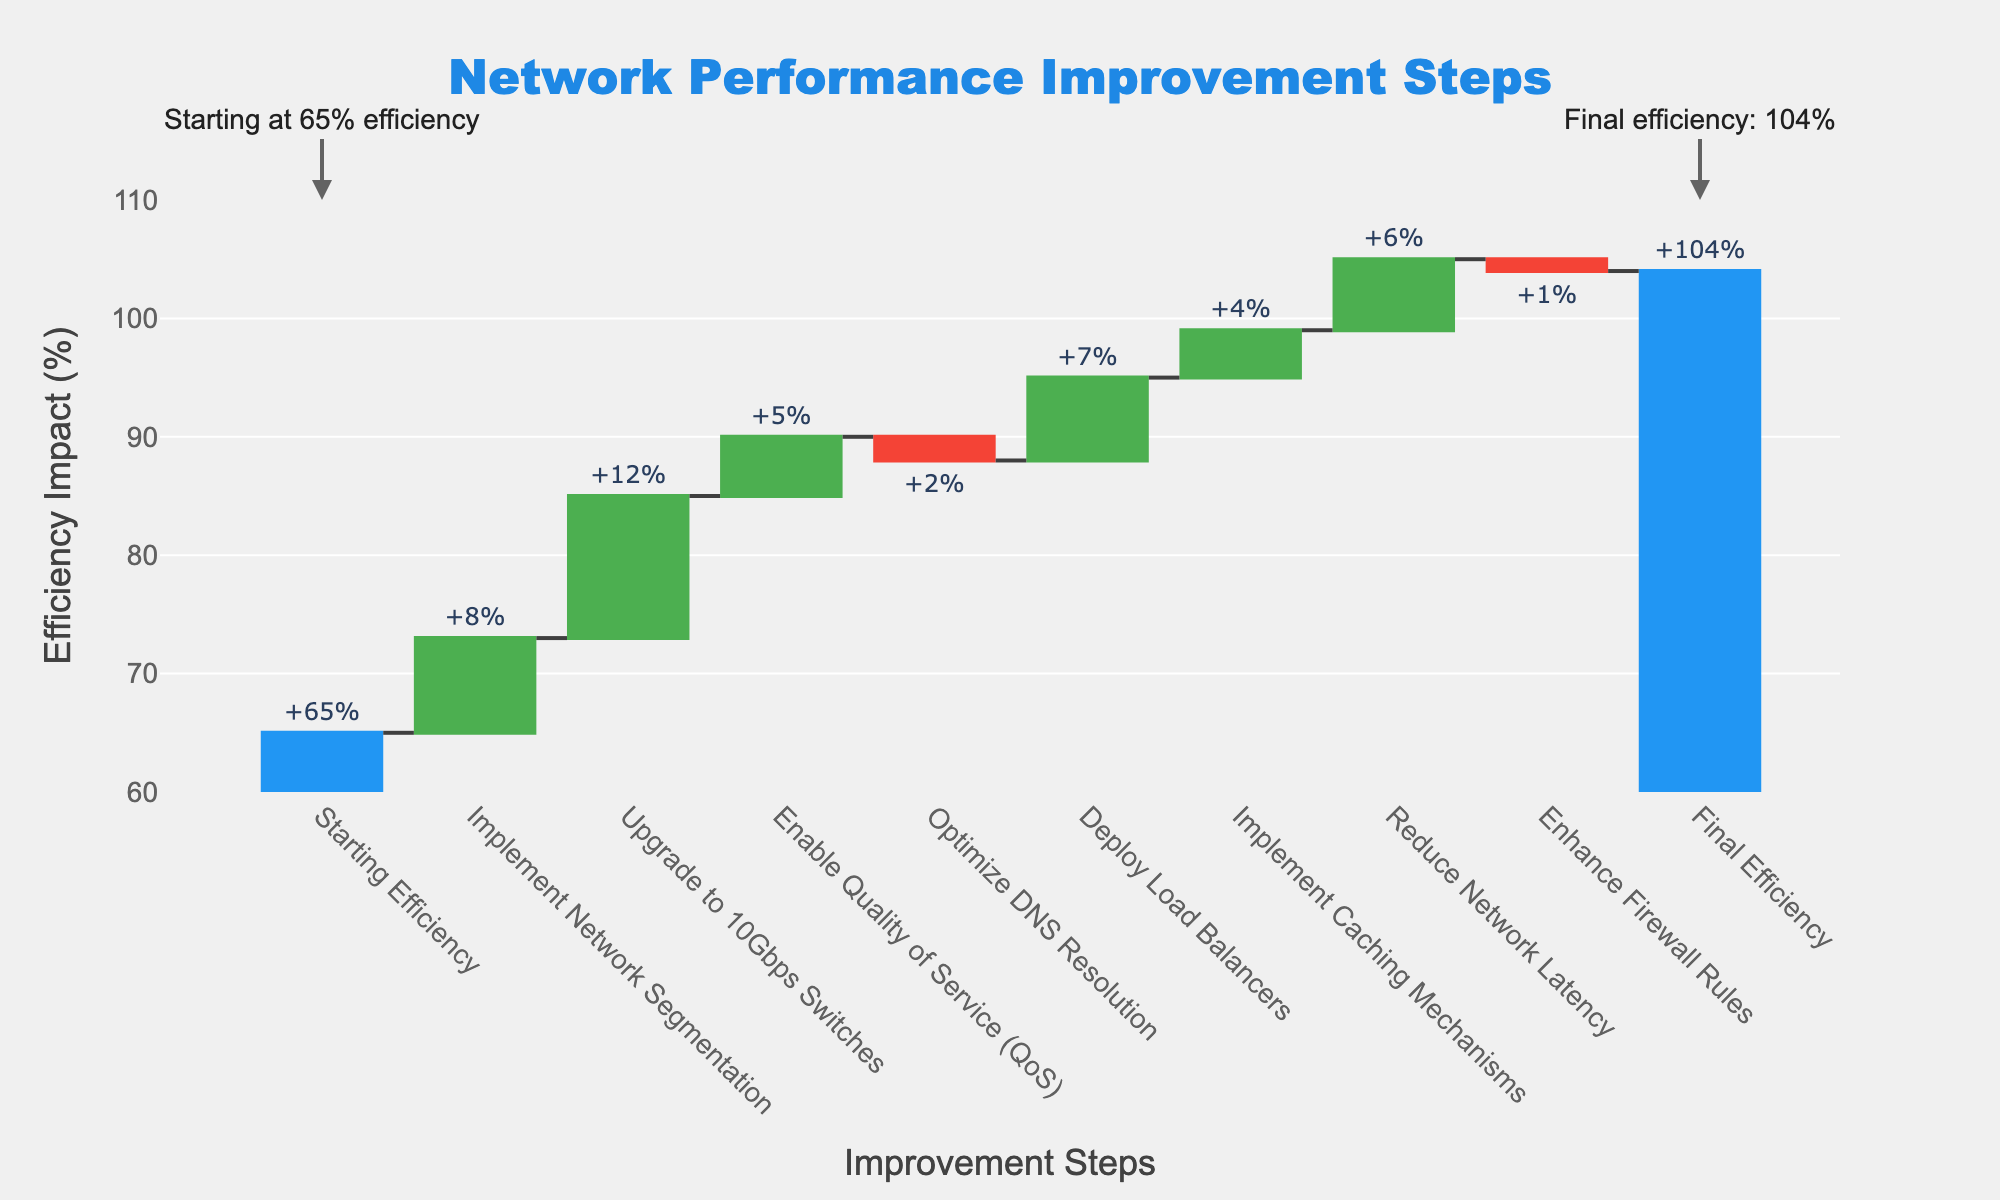What is the starting efficiency value? The starting efficiency value is provided as the first data point in the figure, labeled "Starting Efficiency".
Answer: 65% What does the title of the chart indicate? The title "Network Performance Improvement Steps" indicates that the chart shows the steps taken to improve network performance and their impacts.
Answer: Network Performance Improvement Steps Which improvement step had the highest positive impact on system efficiency? To find the highest positive impact, look for the highest positive bar in the waterfall chart, which corresponds to the label "Upgrade to 10Gbps Switches" with an impact of +12%.
Answer: Upgrade to 10Gbps Switches What is the final efficiency of the system after all improvement steps? The final efficiency value is shown as the last data point in the figure, labeled "Final Efficiency".
Answer: 104% How many improvement steps overall increased system efficiency? Count the number of positive impacts in the chart. The steps that increased efficiency are "Implement Network Segmentation", "Upgrade to 10Gbps Switches", "Enable Quality of Service (QoS)", "Deploy Load Balancers", "Implement Caching Mechanisms", and "Reduce Network Latency".
Answer: 6 What is the combined impact of "Optimize DNS Resolution" and "Enhance Firewall Rules" on system efficiency? Add the impacts of both steps: -2% (Optimize DNS Resolution) and -1% (Enhance Firewall Rules).
Answer: -3% Which step had a negative impact on efficiency but to a lesser extent? Compare the negative impacts in the figure. "Enhance Firewall Rules" with -1% had a lesser negative impact compared to "Optimize DNS Resolution" with -2%.
Answer: Enhance Firewall Rules Compare the contributions of "Implement Network Segmentation" and "Deploy Load Balancers" to the overall efficiency. Which is greater and by how much? "Implement Network Segmentation" contributes +8% and "Deploy Load Balancers" contributes +7%. The difference is +8% - +7% = +1%.
Answer: Implement Network Segmentation by +1% What is the net efficiency gain/loss due to all improvement steps except for the one with the highest positive impact? Sum all impacts except "Upgrade to 10Gbps Switches" (+12%), so: +8 + 5 - 2 + 7 + 4 + 6 - 1 = 27%.
Answer: +27% What is the total increase in system efficiency after all improvement steps? Compare the final efficiency (104%) with the starting efficiency (65%): 104% - 65% = 39%.
Answer: +39% 